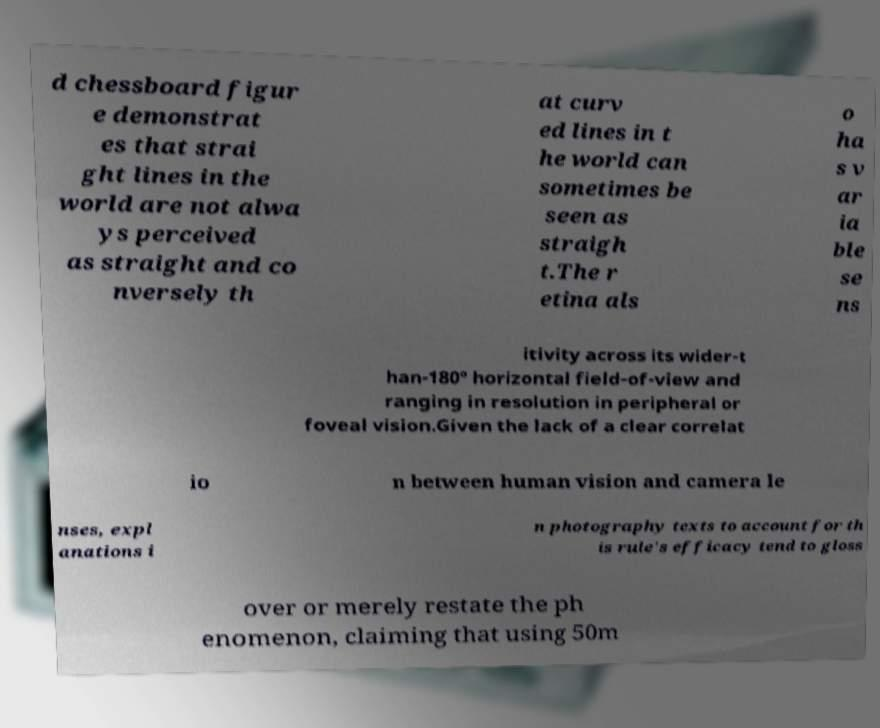Can you read and provide the text displayed in the image?This photo seems to have some interesting text. Can you extract and type it out for me? d chessboard figur e demonstrat es that strai ght lines in the world are not alwa ys perceived as straight and co nversely th at curv ed lines in t he world can sometimes be seen as straigh t.The r etina als o ha s v ar ia ble se ns itivity across its wider-t han-180° horizontal field-of-view and ranging in resolution in peripheral or foveal vision.Given the lack of a clear correlat io n between human vision and camera le nses, expl anations i n photography texts to account for th is rule's efficacy tend to gloss over or merely restate the ph enomenon, claiming that using 50m 